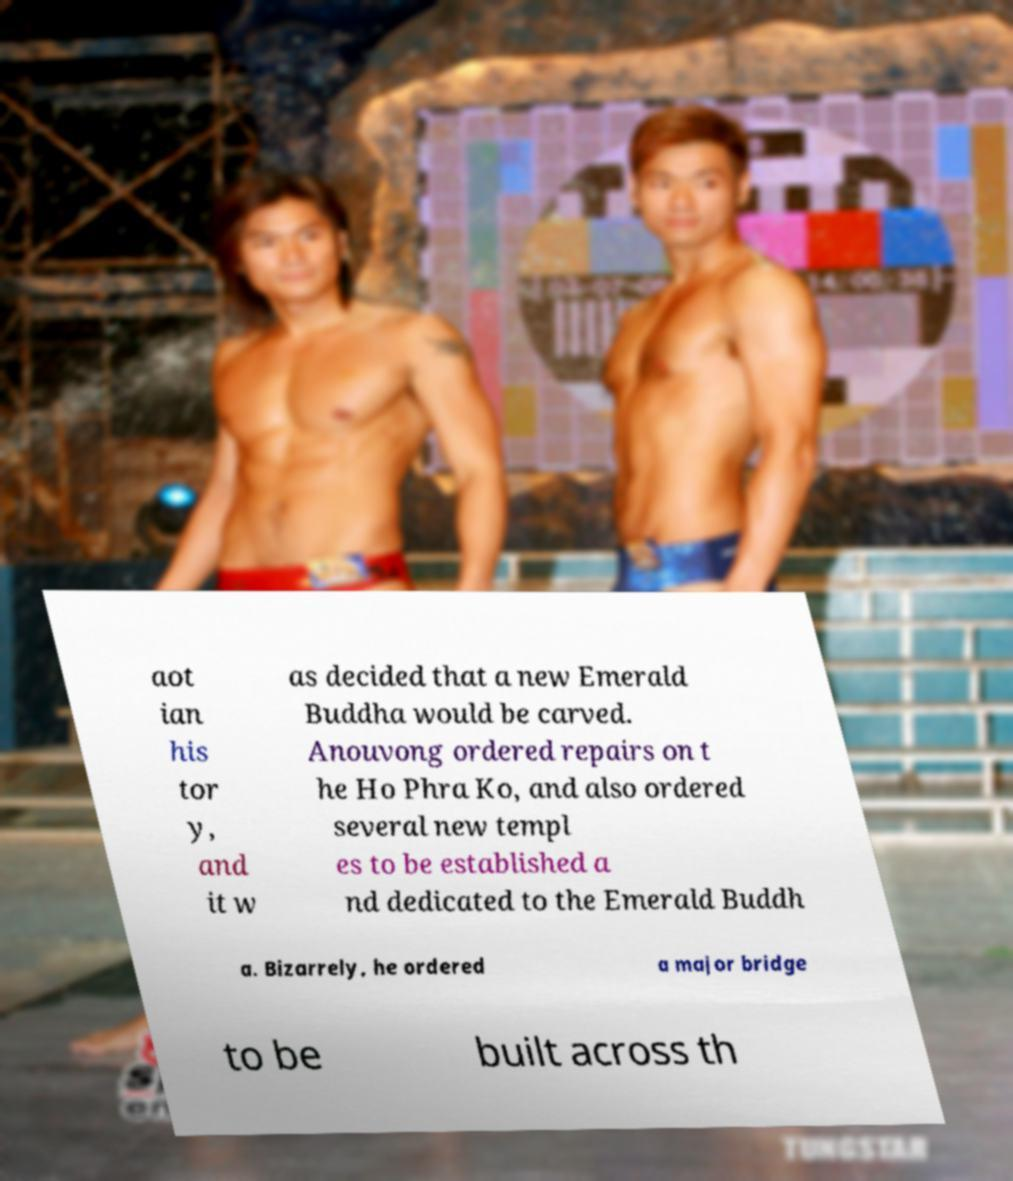Could you assist in decoding the text presented in this image and type it out clearly? aot ian his tor y, and it w as decided that a new Emerald Buddha would be carved. Anouvong ordered repairs on t he Ho Phra Ko, and also ordered several new templ es to be established a nd dedicated to the Emerald Buddh a. Bizarrely, he ordered a major bridge to be built across th 